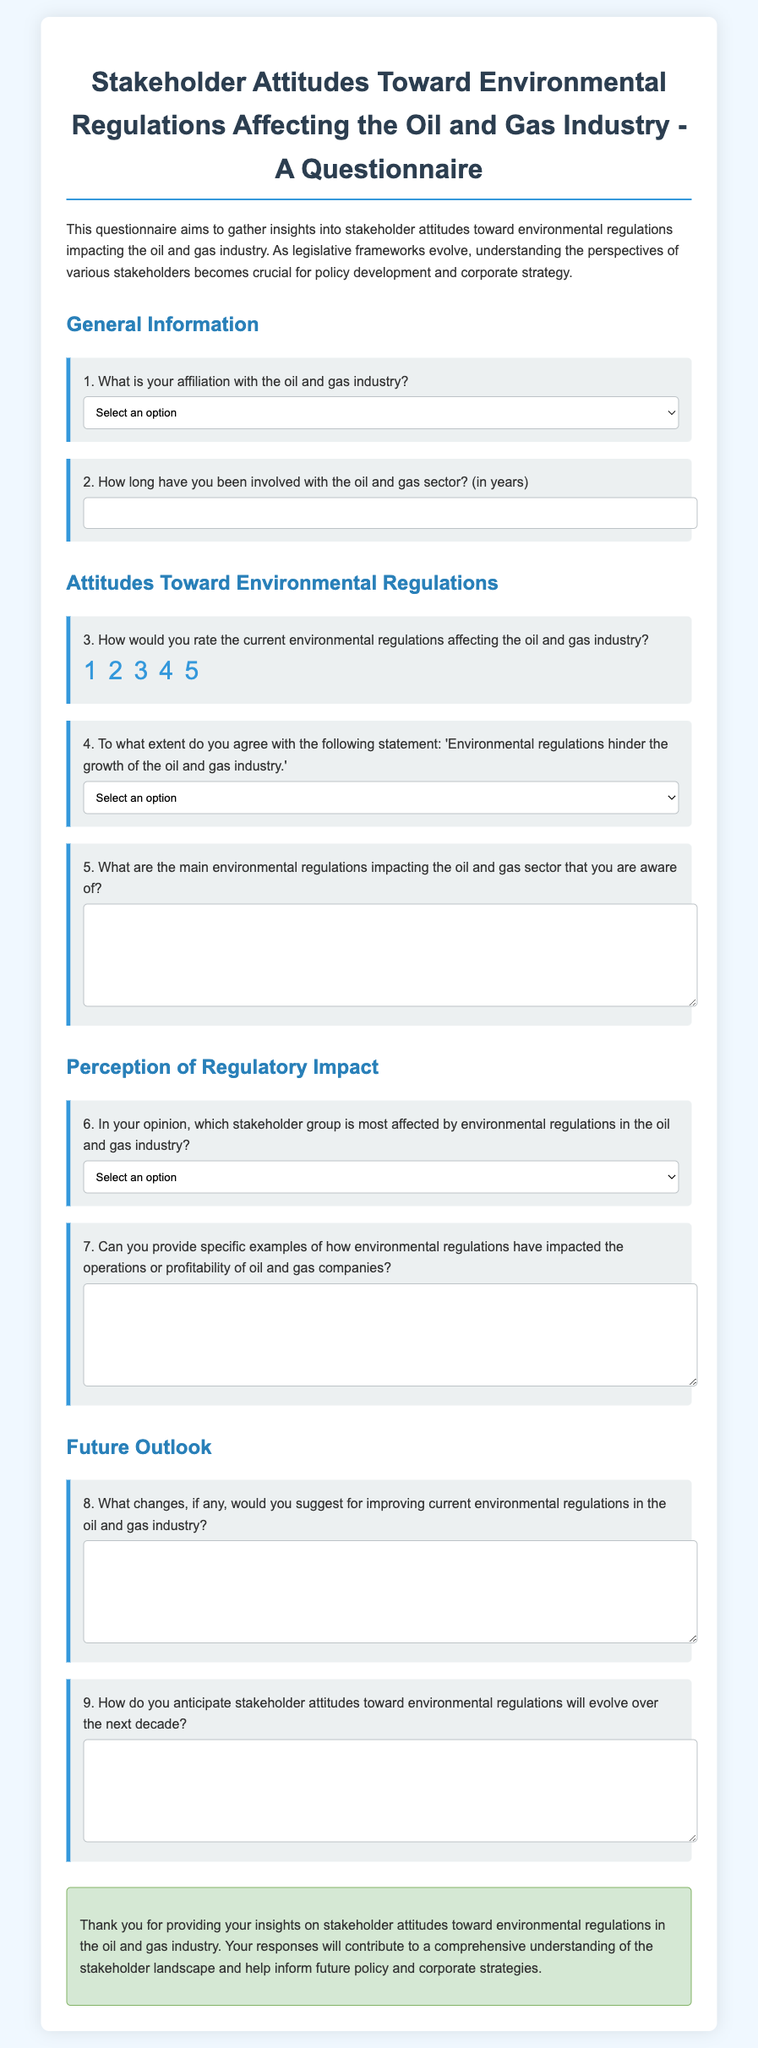What is the title of the questionnaire? The title is provided at the top of the document, summarizing its purpose and focus.
Answer: Stakeholder Attitudes Toward Environmental Regulations Affecting the Oil and Gas Industry - A Questionnaire What percentage of respondents can select "Local Community Member" as their affiliation? The document includes a select option but doesn't provide a percentage; it allows that option for the affiliation question.
Answer: Not applicable How many questions are there in total? The document contains various sections, with a total of nine specific questions regarding stakeholder attitudes.
Answer: 9 Which question number asks about the impact of environmental regulations on oil and gas companies? This question is focused on specific examples concerning the operations or profitability of oil and gas companies.
Answer: 7 What is the minimum number of years for participation in the oil and gas sector asked in the questionnaire? The input field for years has a minimum requirement specified in the document.
Answer: 0 To what extent can respondents agree with the statement about environmental regulations hindering industry growth? The question offers a range of agreement options for respondents to choose from.
Answer: Strongly Disagree to Strongly Agree What type of response format is required for question five? The document specifies a textarea input format for providing detailed answers.
Answer: Textarea What stakeholder group is presented as most affected by environmental regulations? Stakeholders are listed, among which the document indicates there is a specific group perceived as most affected.
Answer: Local Communities What is the primary purpose of this questionnaire? The introduction clearly states the aim of gathering insights into stakeholder attitudes regarding a specific topic.
Answer: Gather insights into stakeholder attitudes 